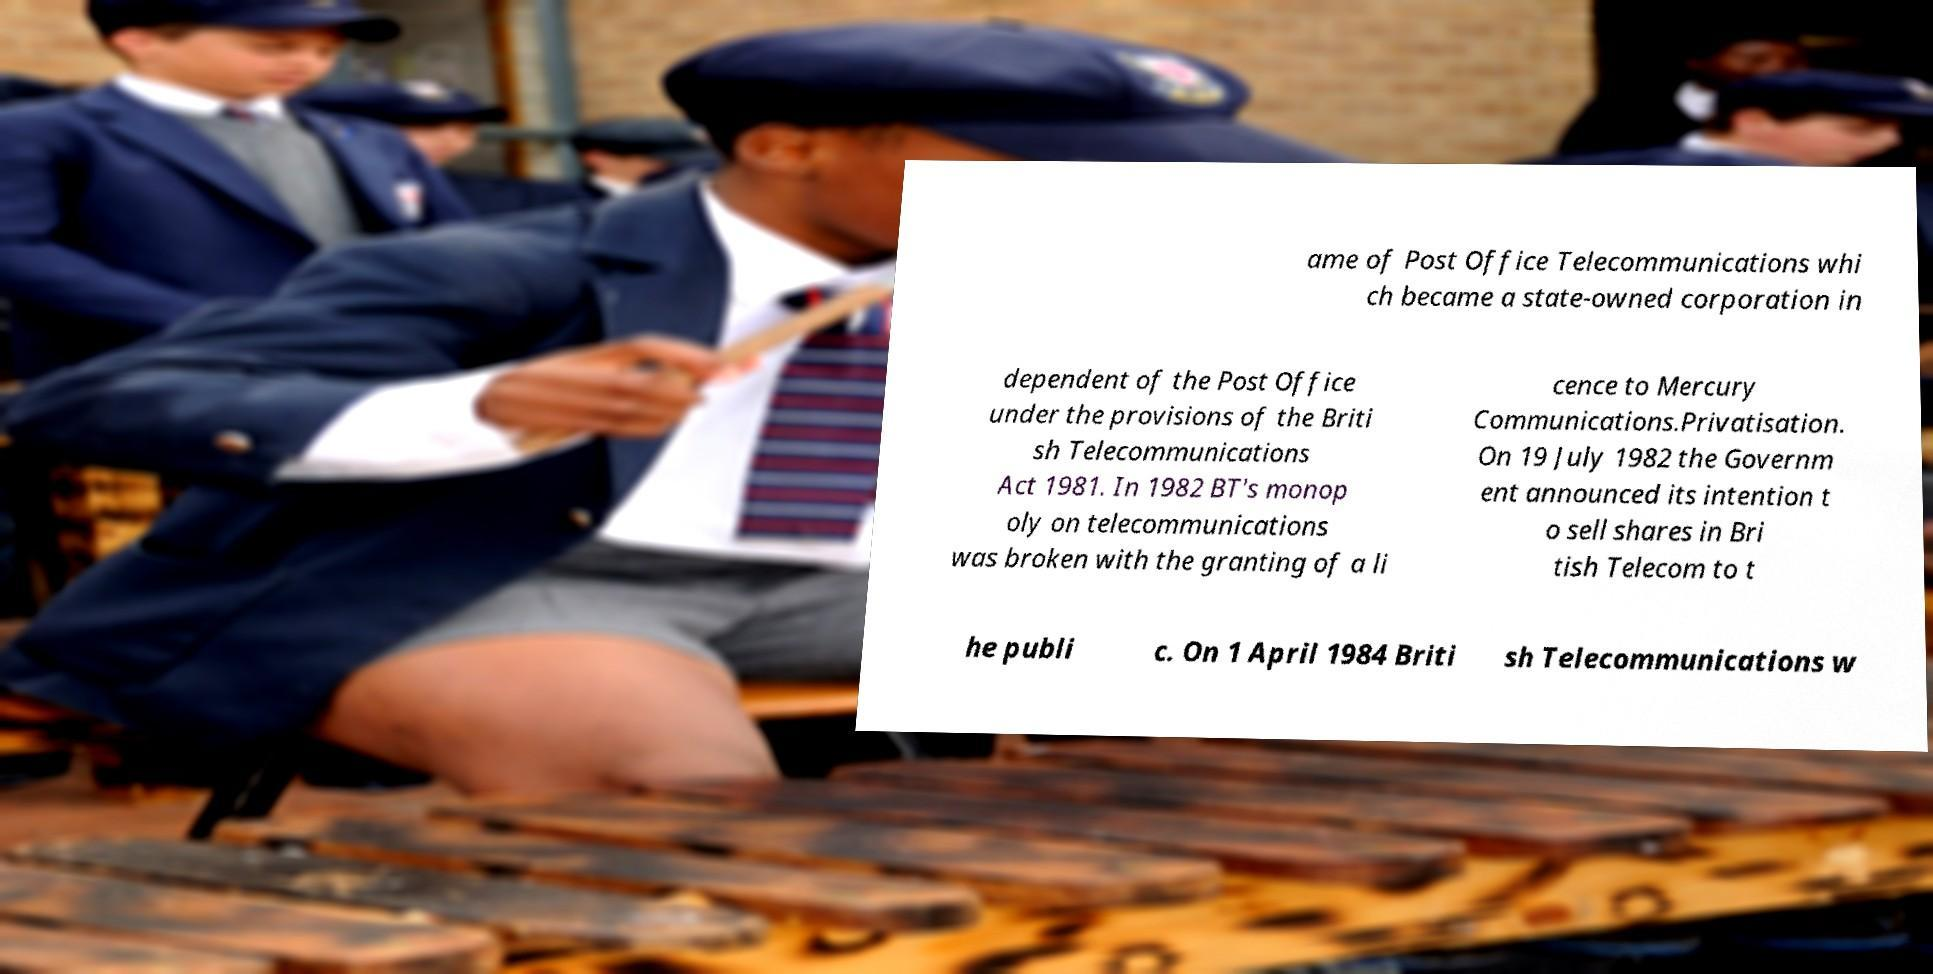There's text embedded in this image that I need extracted. Can you transcribe it verbatim? ame of Post Office Telecommunications whi ch became a state-owned corporation in dependent of the Post Office under the provisions of the Briti sh Telecommunications Act 1981. In 1982 BT's monop oly on telecommunications was broken with the granting of a li cence to Mercury Communications.Privatisation. On 19 July 1982 the Governm ent announced its intention t o sell shares in Bri tish Telecom to t he publi c. On 1 April 1984 Briti sh Telecommunications w 